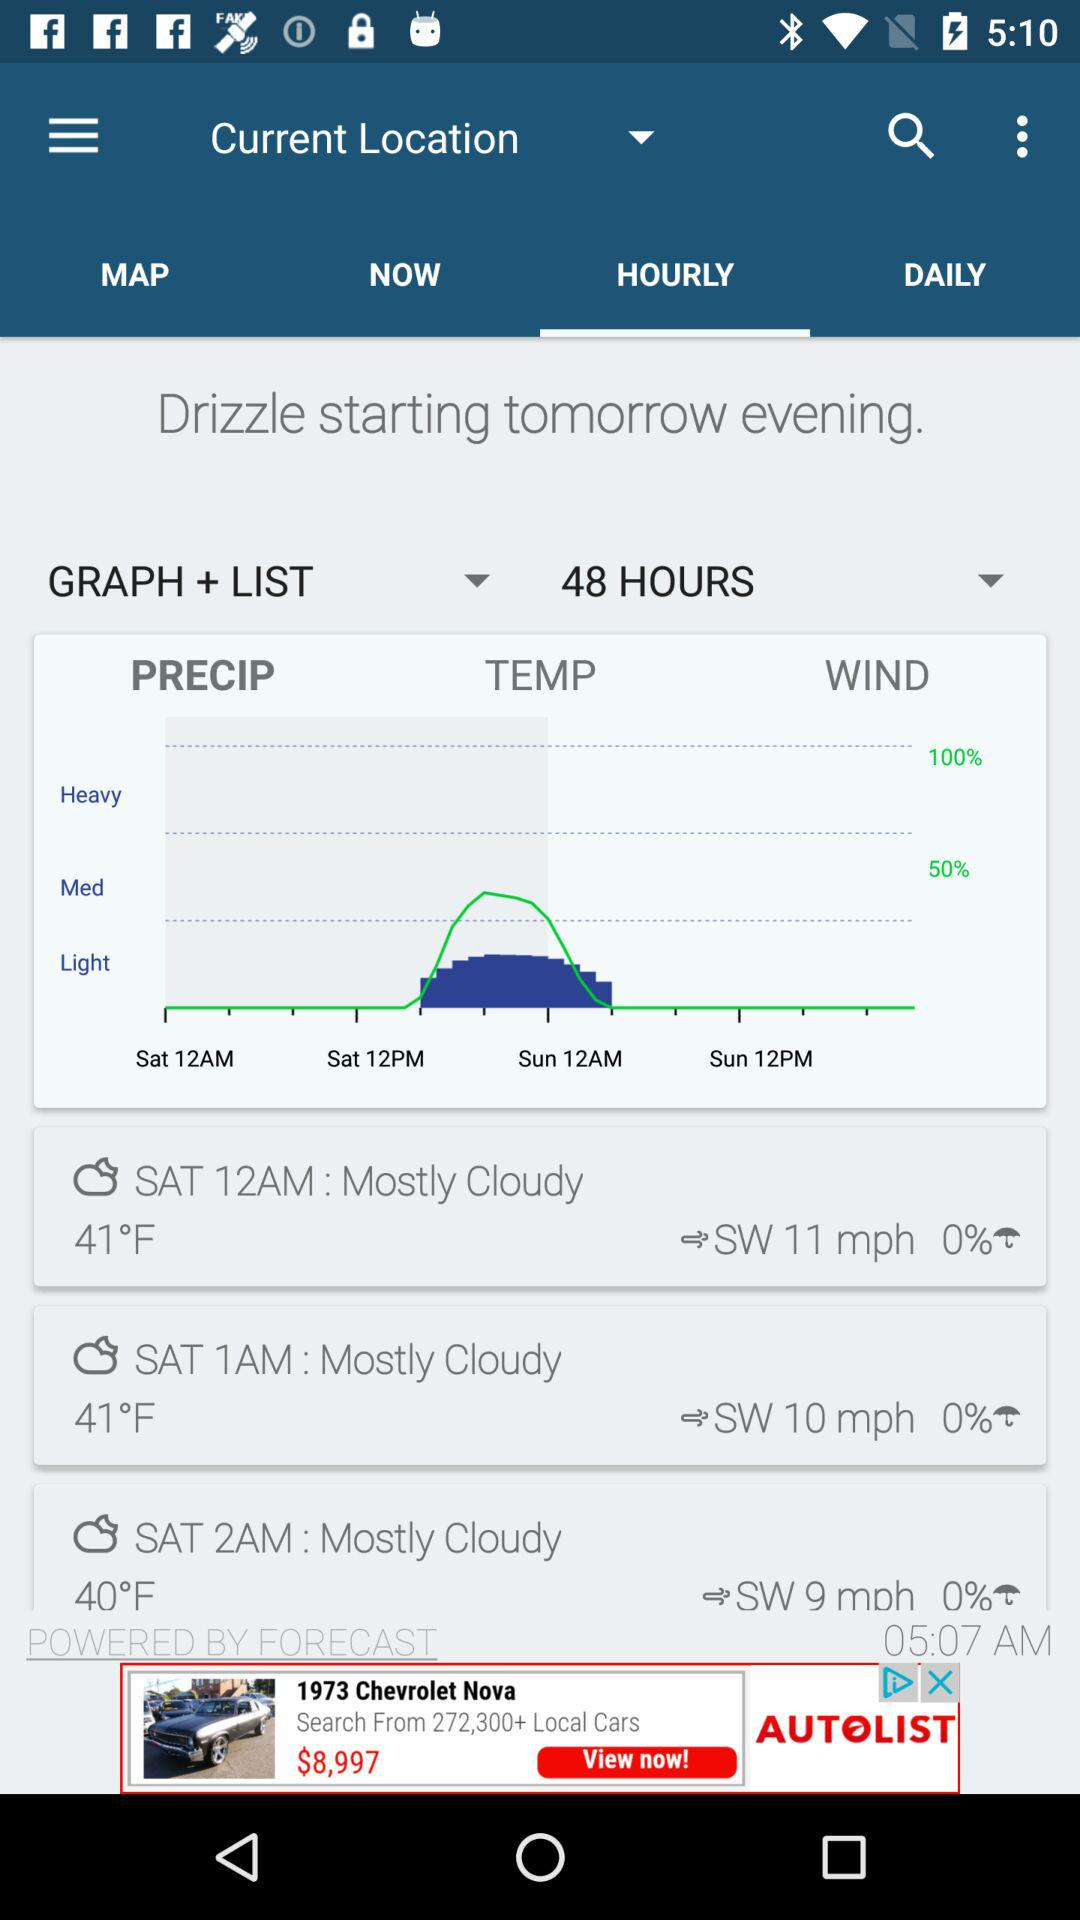Which tab is selected? The selected tab is "HOURLY". 